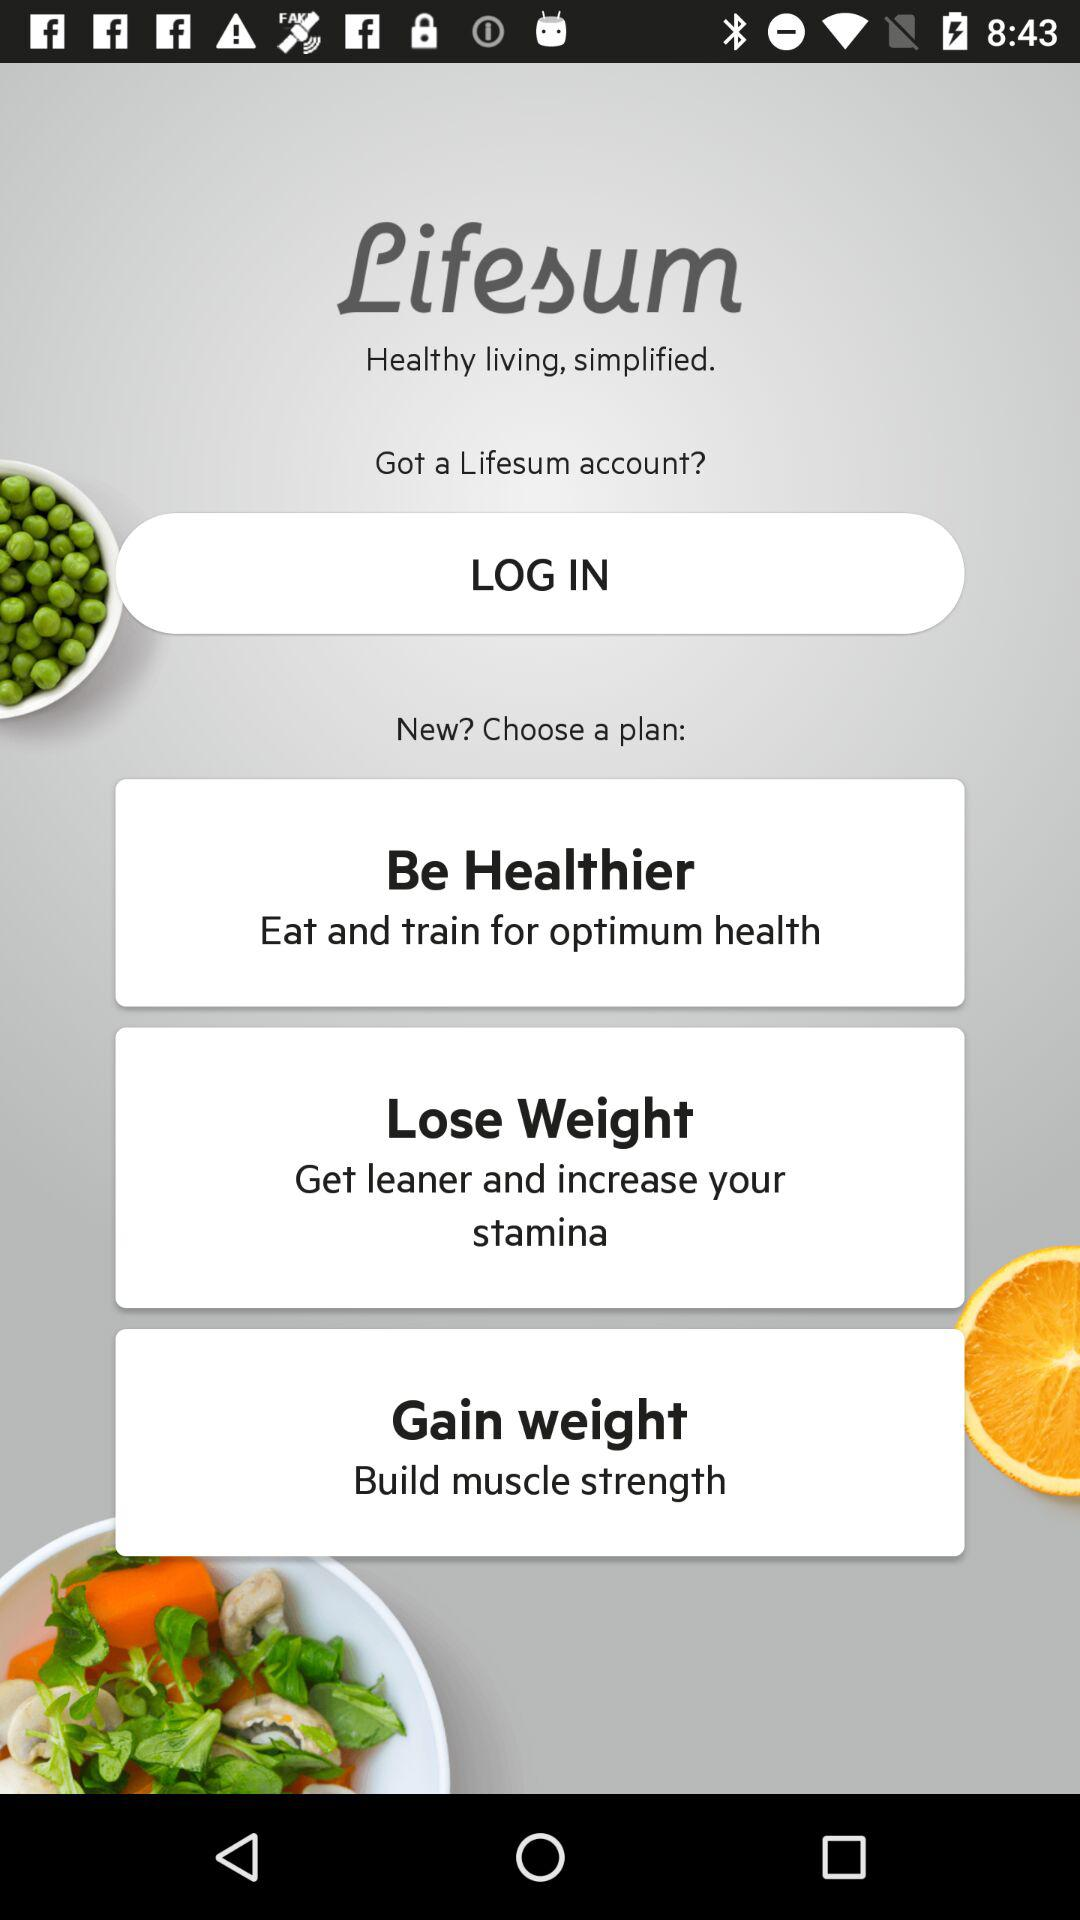How many plans are available to choose from?
Answer the question using a single word or phrase. 3 